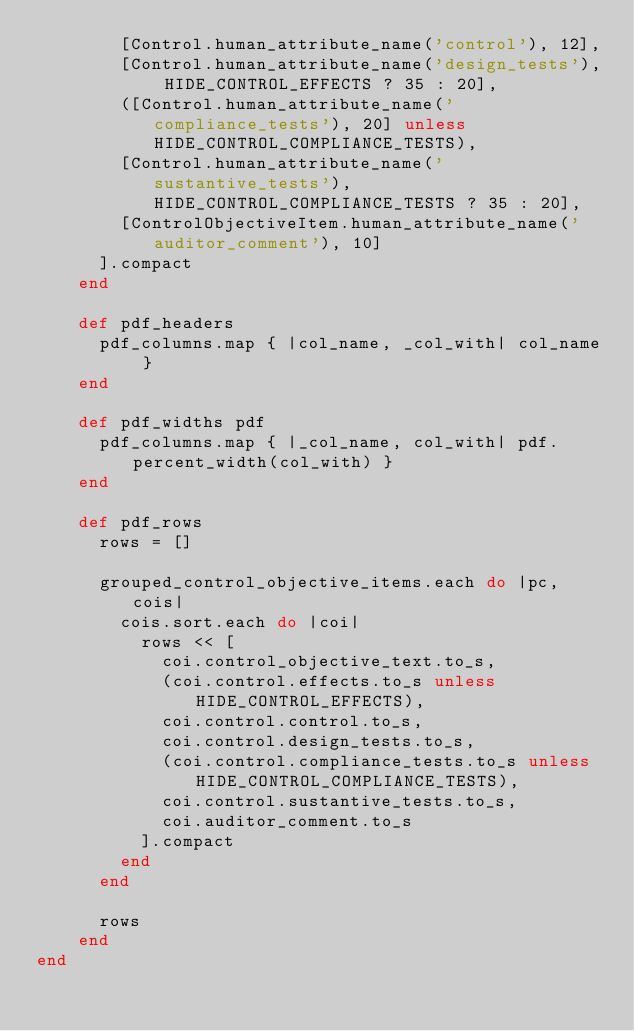<code> <loc_0><loc_0><loc_500><loc_500><_Ruby_>        [Control.human_attribute_name('control'), 12],
        [Control.human_attribute_name('design_tests'), HIDE_CONTROL_EFFECTS ? 35 : 20],
        ([Control.human_attribute_name('compliance_tests'), 20] unless HIDE_CONTROL_COMPLIANCE_TESTS),
        [Control.human_attribute_name('sustantive_tests'), HIDE_CONTROL_COMPLIANCE_TESTS ? 35 : 20],
        [ControlObjectiveItem.human_attribute_name('auditor_comment'), 10]
      ].compact
    end

    def pdf_headers
      pdf_columns.map { |col_name, _col_with| col_name }
    end

    def pdf_widths pdf
      pdf_columns.map { |_col_name, col_with| pdf.percent_width(col_with) }
    end

    def pdf_rows
      rows = []

      grouped_control_objective_items.each do |pc, cois|
        cois.sort.each do |coi|
          rows << [
            coi.control_objective_text.to_s,
            (coi.control.effects.to_s unless HIDE_CONTROL_EFFECTS),
            coi.control.control.to_s,
            coi.control.design_tests.to_s,
            (coi.control.compliance_tests.to_s unless HIDE_CONTROL_COMPLIANCE_TESTS),
            coi.control.sustantive_tests.to_s,
            coi.auditor_comment.to_s
          ].compact
        end
      end

      rows
    end
end
</code> 